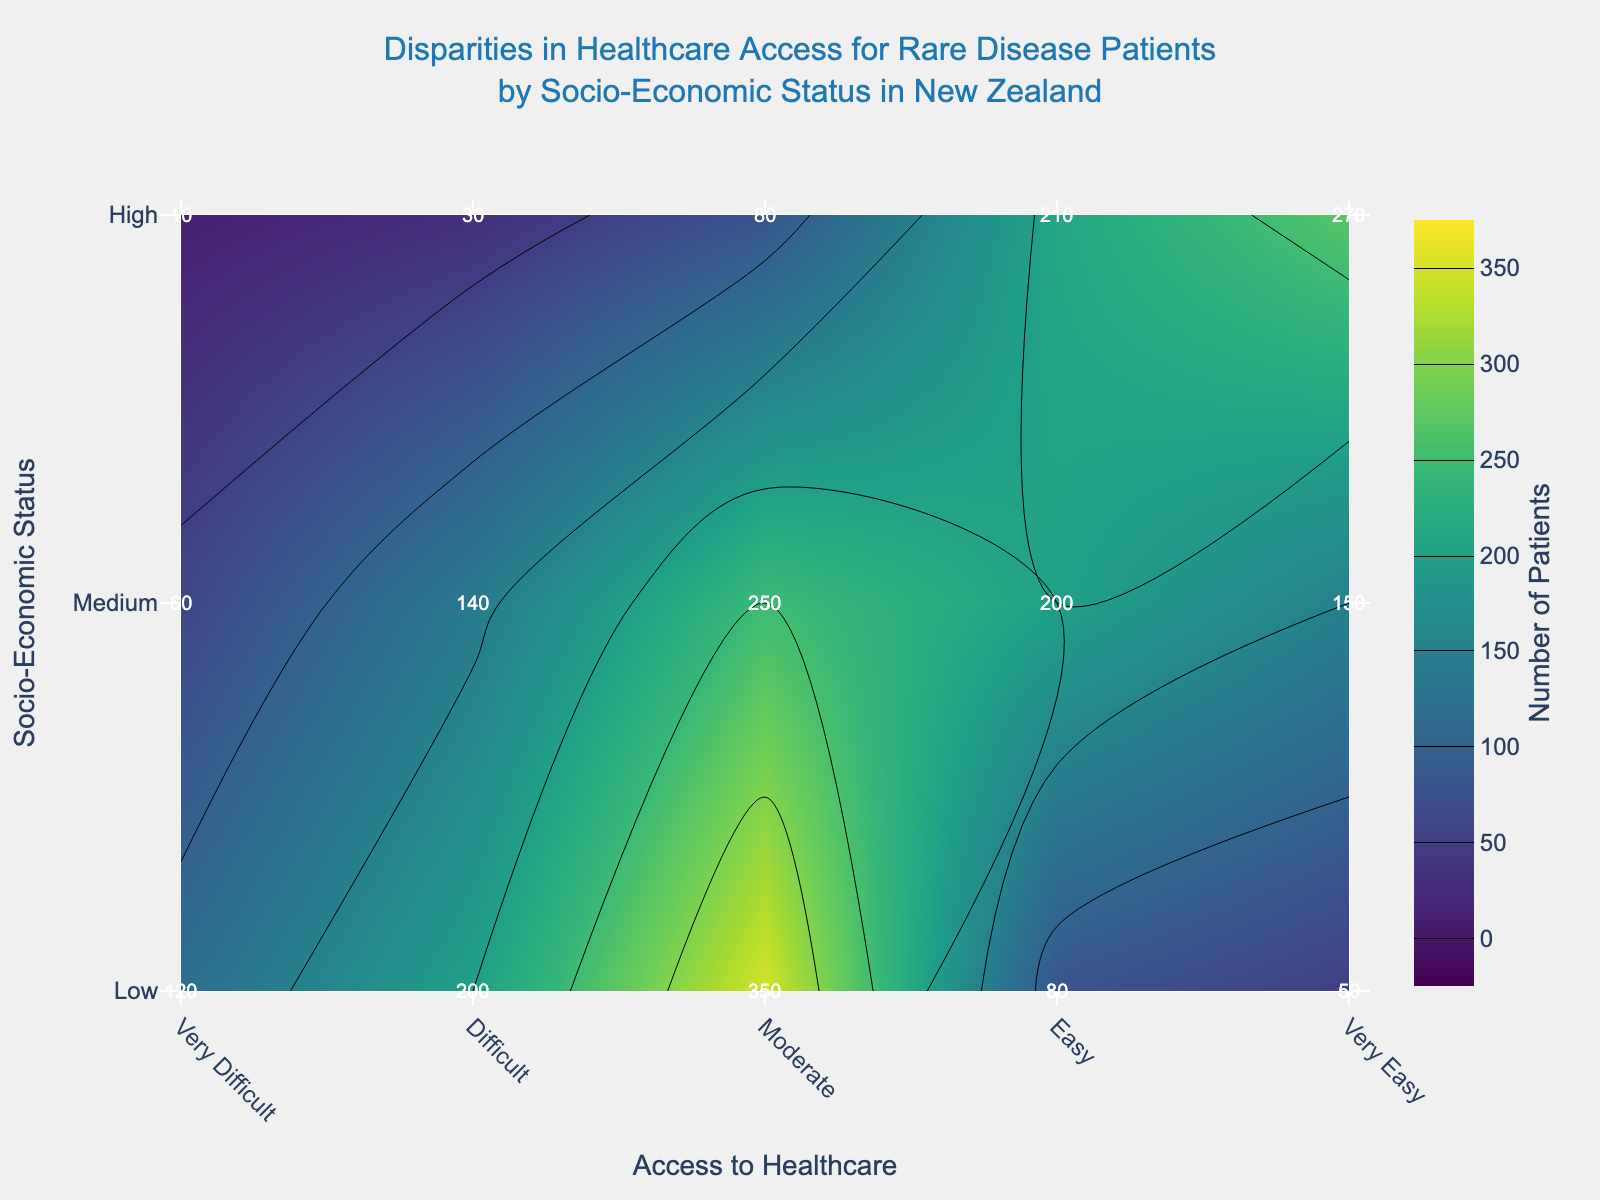What is the title of the figure? The title is usually placed prominently at the top of the figure. It should be easily identifiable by looking at the top-center part of the image.
Answer: Disparities in Healthcare Access for Rare Disease Patients by Socio-Economic Status in New Zealand What does the color scale represent? The color scale usually indicates a specific metric visualized by the contour plot. In this figure, the 'Number of Patients' is associated with different colors, as indicated by the color bar on the side.
Answer: Number of Patients Which socio-economic status group has the highest number of patients with 'Very Easy' access to healthcare? By looking at the row corresponding to 'Very Easy' access to healthcare in the high socio-economic status category, it shows the highest annotation number.
Answer: High Which access level has the largest number of rare disease patients in the 'Medium' socio-economic status? Locate the 'Medium' socio-economic status row and then find the highest labeled number across the 'Access to Healthcare' categories.
Answer: Moderate How does the number of patients with 'Difficult' access differ between 'Low' and 'High' socio-economic statuses? Subtract the number of patients labeled for 'High' socio-economic status from those labeled for 'Low' in the 'Difficult' access category.
Answer: 170 What is the sum of patients with 'Very Difficult' access across all socio-economic statuses? Sum the numbers labeled under 'Very Difficult' access for 'Low', 'Medium', and 'High' socio-economic statuses.
Answer: 190 Among all socio-economic statuses, which access level to healthcare is least represented in the 'Low' group? The 'Low' socio-economic status row shows the lowest number of patients under the 'Very Easy' access level.
Answer: Very Easy Compare the number of patients with 'Moderate' access to healthcare between 'Low' and 'Medium' socio-economic statuses. Which is higher and by how much? Calculate the difference between the number of patients labeled under 'Moderate' access for 'Medium' and 'Low' socio-economic statuses.
Answer: Low, 100 fewer patients Which socio-economic group has the least number of patients with 'Easy' access to healthcare? Identify the smallest number in the 'Easy' access to healthcare column across all socio-economic status rows.
Answer: Low What trend can you observe about healthcare access as socio-economic status improves? Note the general increase or decrease in numbers across the 'Access to Healthcare' categories as you move from 'Low' to 'High' along the y-axis.
Answer: Access improves 